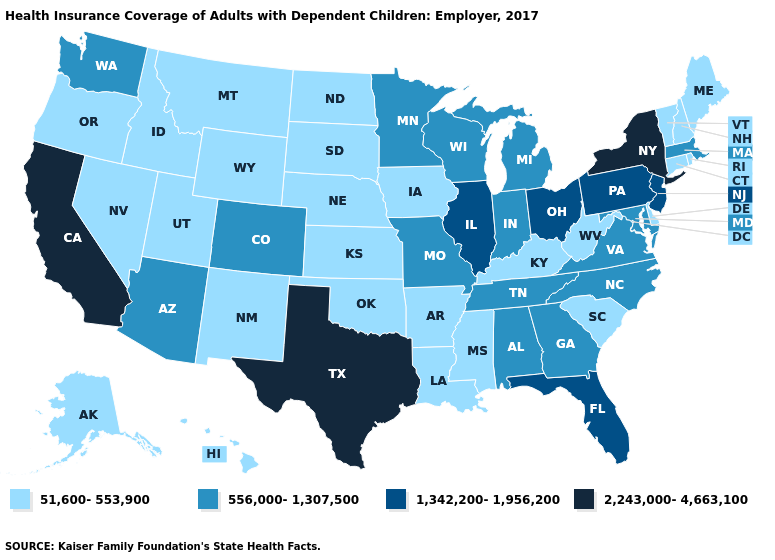Among the states that border Missouri , which have the lowest value?
Give a very brief answer. Arkansas, Iowa, Kansas, Kentucky, Nebraska, Oklahoma. What is the value of Mississippi?
Concise answer only. 51,600-553,900. Does Pennsylvania have the highest value in the Northeast?
Keep it brief. No. What is the highest value in states that border Ohio?
Keep it brief. 1,342,200-1,956,200. What is the value of Illinois?
Write a very short answer. 1,342,200-1,956,200. Is the legend a continuous bar?
Answer briefly. No. Does Nebraska have the highest value in the MidWest?
Answer briefly. No. What is the lowest value in states that border Florida?
Quick response, please. 556,000-1,307,500. Which states have the lowest value in the South?
Keep it brief. Arkansas, Delaware, Kentucky, Louisiana, Mississippi, Oklahoma, South Carolina, West Virginia. What is the value of Florida?
Short answer required. 1,342,200-1,956,200. Does New York have the highest value in the USA?
Answer briefly. Yes. Does Missouri have the highest value in the USA?
Concise answer only. No. How many symbols are there in the legend?
Answer briefly. 4. What is the lowest value in the West?
Concise answer only. 51,600-553,900. Name the states that have a value in the range 1,342,200-1,956,200?
Quick response, please. Florida, Illinois, New Jersey, Ohio, Pennsylvania. 